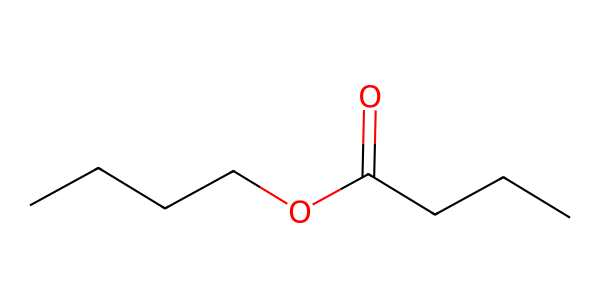What is the name of the ester represented by this structure? The structure corresponds to butyl butyrate, which is an ester derived from butanoic acid and butanol. The SMILES notation helps identify the components of the ester, leading to its name.
Answer: butyl butyrate How many carbon atoms are in butyl butyrate? The chemical structure shows a total of six carbon atoms (four from the butyl group and two from the butyrate group). Counting the carbon atoms from the SMILES representation confirms this count.
Answer: six What type of functional group is present in butyl butyrate? The SMILES representation indicates the presence of an ester functional group, which is characterized by the carbonyl (C=O) within the structure, connected to an ether (C-O) component. This unique combination confirms its classification as an ester.
Answer: ester What are the total hydrogen atoms in butyl butyrate? By analyzing the carbon and oxygen atoms in the structure, the total count reveals there are twelve hydrogen atoms. Each carbon contributes to the overall number of hydrogens based on its bonding configuration in the ester.
Answer: twelve What effect does butyl butyrate have on food aroma? Butyl butyrate is known to provide a sweet, fruity aroma, often associated with mangoes. The specific structure and composition of this ester contribute to its characteristic scent, which is why it's commonly found in food flavorings.
Answer: fruity aroma What is the molecular formula of butyl butyrate? Based on the identified atoms (6 carbons, 12 hydrogens, and 2 oxygens), the molecular formula can be deduced to be C6H12O2. The counting is performed using the SMILES notation as a guide to establish the correct ratio.
Answer: C6H12O2 